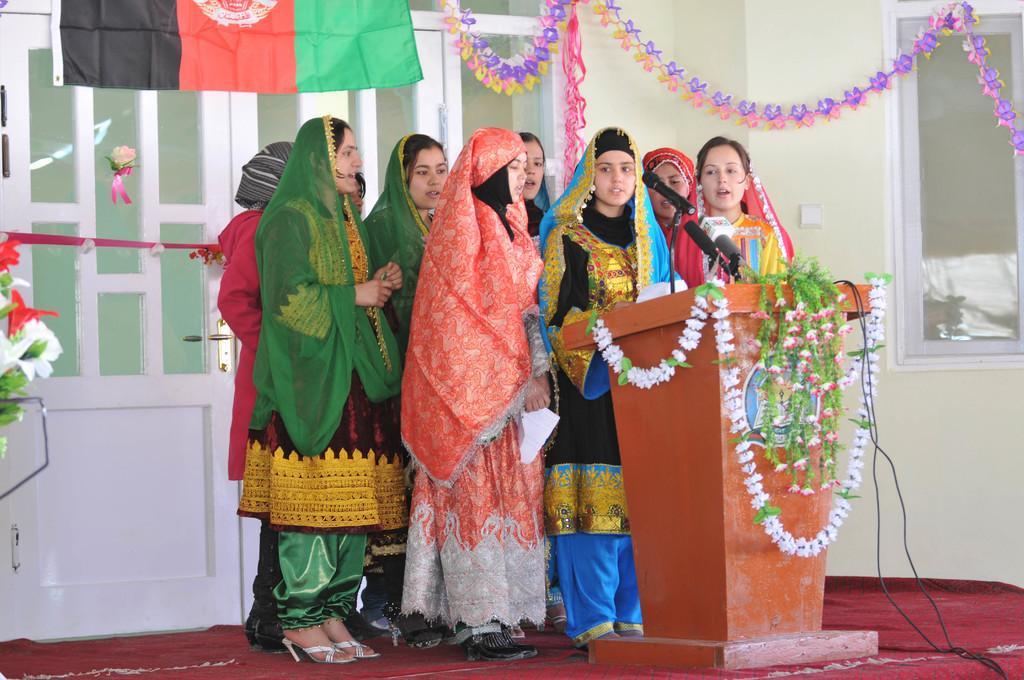Can you describe this image briefly? In this image in the front there is a podium, on the podium there are flowers and on the top of the podium there are mice and wires and in the center there are persons standing and singing. In the background there are flowers, there is a door, window and there is a flag. On the ground there is a mat which is red in colour. 